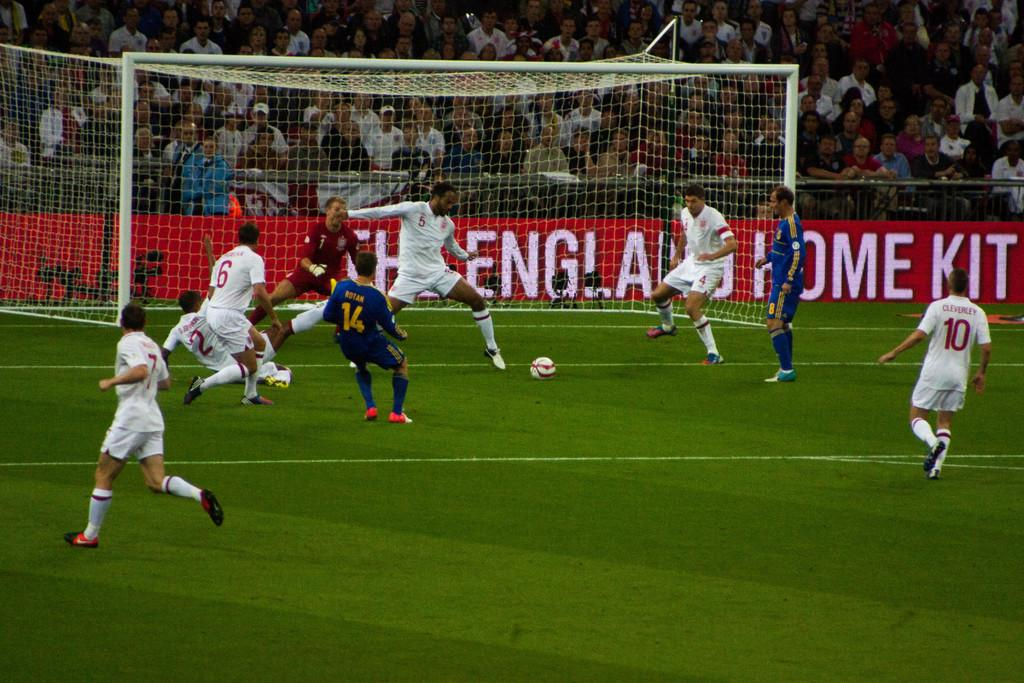Provide a one-sentence caption for the provided image. Soccer players playing game on the field including the one named Rotan. 